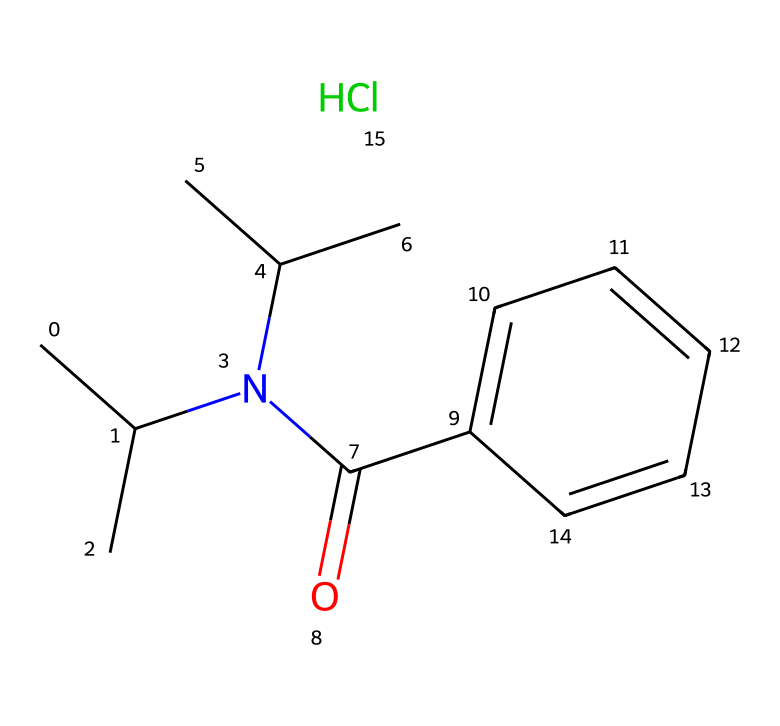How many carbon atoms are in this compound? By analyzing the SMILES representation, we can count the 'C' characters. Each 'C' represents a carbon atom, and there are 10 'C' characters in total, indicating 10 carbon atoms.
Answer: 10 What is the molecular formula derived from this structure? The structure contains 10 carbon (C) atoms, 15 hydrogen (H) atoms, 1 nitrogen (N) atom, 1 oxygen (O) atom, and 1 chlorine (Cl) atom. Combining these results gives us the molecular formula C10H15ClN2O.
Answer: C10H15ClN2O What functional groups are present in this chemical? Looking at the structure, we can identify a carbonyl (C=O) group and a chloride (Cl) group. The presence of these groups indicates that this compound has a ketone and a halogen functional group.
Answer: carbonyl and chloride What can be inferred about the potential solubility of this compound in water? Given the presence of a nitrogen atom and a chloride group, which can interact with water, the compound is likely to have moderate solubility. However, the overall hydrophobic character due to multiple carbon atoms suggests less solubility than polar compounds.
Answer: moderate Is this compound likely to be an anesthetic based on its structure? The structure has characteristics typical of anesthetics, such as the presence of a nitrogen atom and a branched alkyl chain, which commonly appear in many anesthetics. Therefore, it is reasonable to deduce that this compound is likely an anesthetic.
Answer: likely an anesthetic 